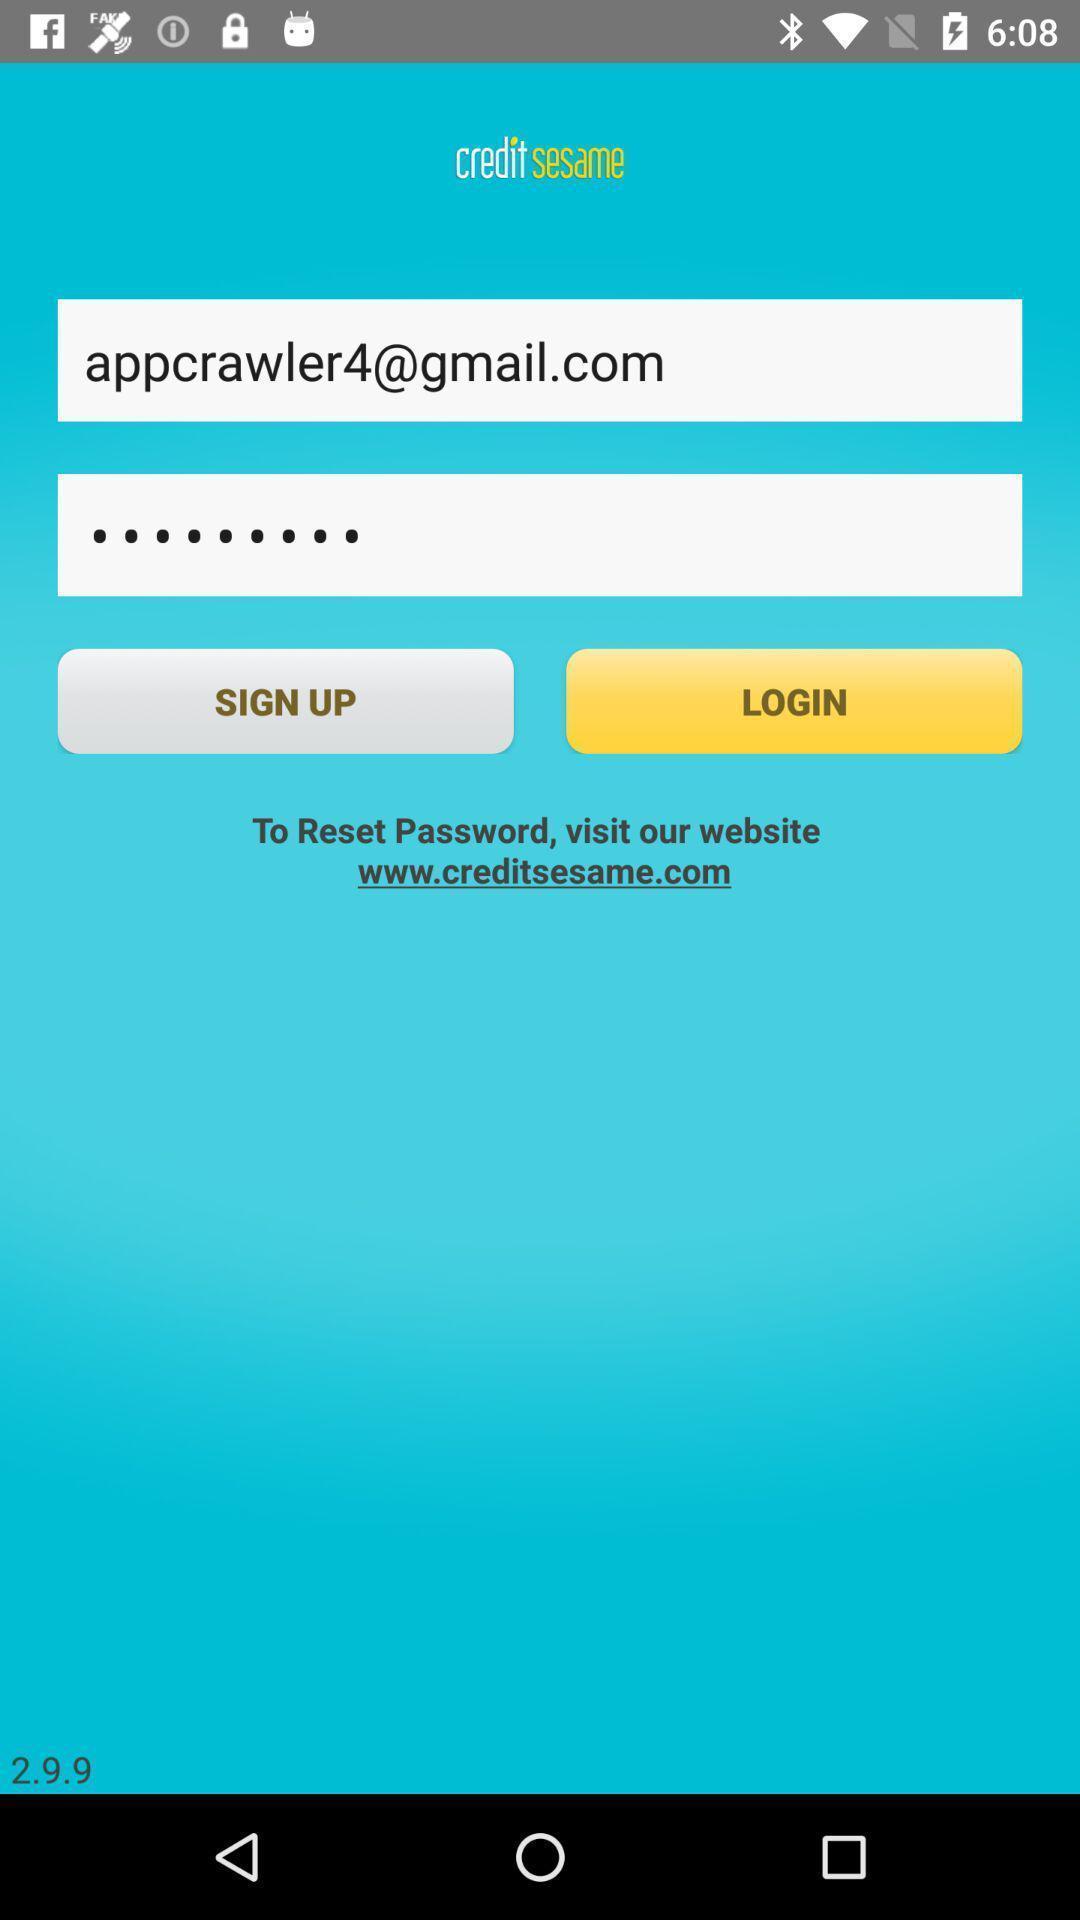What details can you identify in this image? Welcome to the login page. 